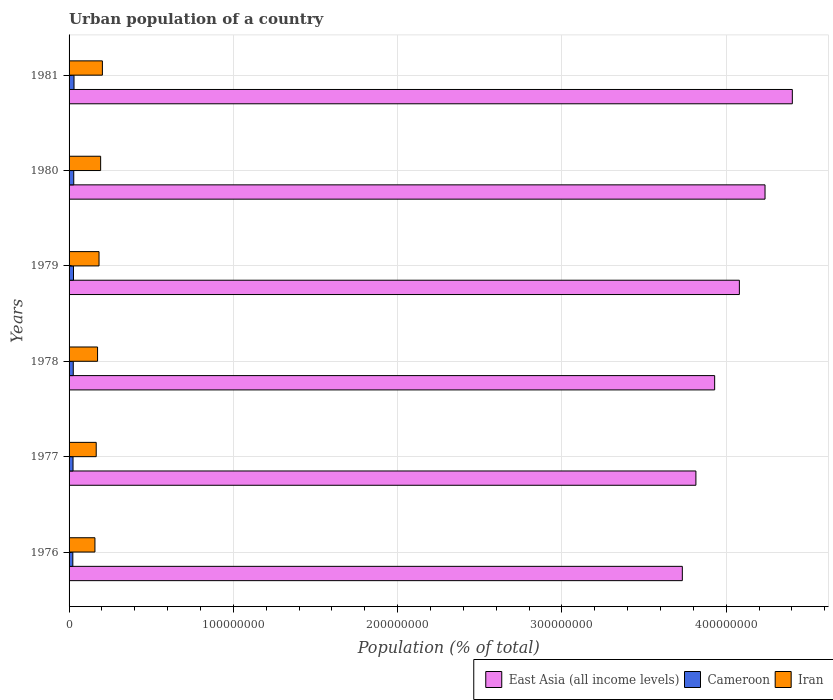How many different coloured bars are there?
Ensure brevity in your answer.  3. How many groups of bars are there?
Make the answer very short. 6. What is the label of the 6th group of bars from the top?
Your answer should be very brief. 1976. In how many cases, is the number of bars for a given year not equal to the number of legend labels?
Your answer should be very brief. 0. What is the urban population in Iran in 1977?
Your answer should be very brief. 1.65e+07. Across all years, what is the maximum urban population in Iran?
Your response must be concise. 2.03e+07. Across all years, what is the minimum urban population in Cameroon?
Offer a very short reply. 2.28e+06. In which year was the urban population in Iran maximum?
Your response must be concise. 1981. In which year was the urban population in Cameroon minimum?
Your answer should be very brief. 1976. What is the total urban population in Iran in the graph?
Ensure brevity in your answer.  1.07e+08. What is the difference between the urban population in Iran in 1978 and that in 1981?
Give a very brief answer. -2.93e+06. What is the difference between the urban population in Iran in 1978 and the urban population in Cameroon in 1977?
Give a very brief answer. 1.49e+07. What is the average urban population in Cameroon per year?
Offer a terse response. 2.63e+06. In the year 1976, what is the difference between the urban population in Cameroon and urban population in Iran?
Offer a terse response. -1.35e+07. What is the ratio of the urban population in East Asia (all income levels) in 1976 to that in 1978?
Ensure brevity in your answer.  0.95. Is the urban population in East Asia (all income levels) in 1976 less than that in 1977?
Your response must be concise. Yes. What is the difference between the highest and the second highest urban population in Iran?
Your response must be concise. 1.06e+06. What is the difference between the highest and the lowest urban population in Iran?
Make the answer very short. 4.53e+06. In how many years, is the urban population in Cameroon greater than the average urban population in Cameroon taken over all years?
Give a very brief answer. 3. Is the sum of the urban population in Cameroon in 1976 and 1978 greater than the maximum urban population in East Asia (all income levels) across all years?
Ensure brevity in your answer.  No. What does the 1st bar from the top in 1979 represents?
Give a very brief answer. Iran. What does the 3rd bar from the bottom in 1981 represents?
Ensure brevity in your answer.  Iran. Are all the bars in the graph horizontal?
Your response must be concise. Yes. How many years are there in the graph?
Make the answer very short. 6. What is the difference between two consecutive major ticks on the X-axis?
Offer a very short reply. 1.00e+08. Are the values on the major ticks of X-axis written in scientific E-notation?
Offer a terse response. No. Does the graph contain grids?
Your answer should be very brief. Yes. Where does the legend appear in the graph?
Your answer should be very brief. Bottom right. How many legend labels are there?
Make the answer very short. 3. How are the legend labels stacked?
Your answer should be compact. Horizontal. What is the title of the graph?
Give a very brief answer. Urban population of a country. What is the label or title of the X-axis?
Offer a very short reply. Population (% of total). What is the label or title of the Y-axis?
Offer a very short reply. Years. What is the Population (% of total) in East Asia (all income levels) in 1976?
Your answer should be very brief. 3.73e+08. What is the Population (% of total) in Cameroon in 1976?
Ensure brevity in your answer.  2.28e+06. What is the Population (% of total) of Iran in 1976?
Your answer should be very brief. 1.57e+07. What is the Population (% of total) of East Asia (all income levels) in 1977?
Provide a short and direct response. 3.82e+08. What is the Population (% of total) in Cameroon in 1977?
Your response must be concise. 2.41e+06. What is the Population (% of total) of Iran in 1977?
Your answer should be compact. 1.65e+07. What is the Population (% of total) of East Asia (all income levels) in 1978?
Give a very brief answer. 3.93e+08. What is the Population (% of total) of Cameroon in 1978?
Your response must be concise. 2.55e+06. What is the Population (% of total) of Iran in 1978?
Ensure brevity in your answer.  1.73e+07. What is the Population (% of total) in East Asia (all income levels) in 1979?
Offer a terse response. 4.08e+08. What is the Population (% of total) of Cameroon in 1979?
Give a very brief answer. 2.70e+06. What is the Population (% of total) in Iran in 1979?
Make the answer very short. 1.82e+07. What is the Population (% of total) of East Asia (all income levels) in 1980?
Your response must be concise. 4.24e+08. What is the Population (% of total) of Cameroon in 1980?
Your answer should be compact. 2.85e+06. What is the Population (% of total) in Iran in 1980?
Make the answer very short. 1.92e+07. What is the Population (% of total) of East Asia (all income levels) in 1981?
Give a very brief answer. 4.40e+08. What is the Population (% of total) of Cameroon in 1981?
Your answer should be compact. 3.01e+06. What is the Population (% of total) of Iran in 1981?
Your response must be concise. 2.03e+07. Across all years, what is the maximum Population (% of total) of East Asia (all income levels)?
Provide a succinct answer. 4.40e+08. Across all years, what is the maximum Population (% of total) in Cameroon?
Give a very brief answer. 3.01e+06. Across all years, what is the maximum Population (% of total) of Iran?
Offer a terse response. 2.03e+07. Across all years, what is the minimum Population (% of total) of East Asia (all income levels)?
Make the answer very short. 3.73e+08. Across all years, what is the minimum Population (% of total) of Cameroon?
Your answer should be very brief. 2.28e+06. Across all years, what is the minimum Population (% of total) of Iran?
Offer a very short reply. 1.57e+07. What is the total Population (% of total) in East Asia (all income levels) in the graph?
Offer a very short reply. 2.42e+09. What is the total Population (% of total) of Cameroon in the graph?
Your answer should be compact. 1.58e+07. What is the total Population (% of total) of Iran in the graph?
Ensure brevity in your answer.  1.07e+08. What is the difference between the Population (% of total) of East Asia (all income levels) in 1976 and that in 1977?
Keep it short and to the point. -8.27e+06. What is the difference between the Population (% of total) in Cameroon in 1976 and that in 1977?
Your answer should be very brief. -1.30e+05. What is the difference between the Population (% of total) of Iran in 1976 and that in 1977?
Provide a succinct answer. -7.82e+05. What is the difference between the Population (% of total) of East Asia (all income levels) in 1976 and that in 1978?
Provide a succinct answer. -1.97e+07. What is the difference between the Population (% of total) in Cameroon in 1976 and that in 1978?
Your response must be concise. -2.68e+05. What is the difference between the Population (% of total) of Iran in 1976 and that in 1978?
Provide a short and direct response. -1.60e+06. What is the difference between the Population (% of total) in East Asia (all income levels) in 1976 and that in 1979?
Offer a terse response. -3.47e+07. What is the difference between the Population (% of total) in Cameroon in 1976 and that in 1979?
Make the answer very short. -4.14e+05. What is the difference between the Population (% of total) of Iran in 1976 and that in 1979?
Provide a succinct answer. -2.49e+06. What is the difference between the Population (% of total) in East Asia (all income levels) in 1976 and that in 1980?
Your answer should be very brief. -5.03e+07. What is the difference between the Population (% of total) of Cameroon in 1976 and that in 1980?
Offer a terse response. -5.69e+05. What is the difference between the Population (% of total) of Iran in 1976 and that in 1980?
Offer a terse response. -3.47e+06. What is the difference between the Population (% of total) in East Asia (all income levels) in 1976 and that in 1981?
Provide a short and direct response. -6.70e+07. What is the difference between the Population (% of total) of Cameroon in 1976 and that in 1981?
Give a very brief answer. -7.32e+05. What is the difference between the Population (% of total) of Iran in 1976 and that in 1981?
Ensure brevity in your answer.  -4.53e+06. What is the difference between the Population (% of total) in East Asia (all income levels) in 1977 and that in 1978?
Make the answer very short. -1.14e+07. What is the difference between the Population (% of total) of Cameroon in 1977 and that in 1978?
Your answer should be compact. -1.38e+05. What is the difference between the Population (% of total) of Iran in 1977 and that in 1978?
Your response must be concise. -8.18e+05. What is the difference between the Population (% of total) in East Asia (all income levels) in 1977 and that in 1979?
Give a very brief answer. -2.65e+07. What is the difference between the Population (% of total) in Cameroon in 1977 and that in 1979?
Ensure brevity in your answer.  -2.84e+05. What is the difference between the Population (% of total) in Iran in 1977 and that in 1979?
Ensure brevity in your answer.  -1.71e+06. What is the difference between the Population (% of total) of East Asia (all income levels) in 1977 and that in 1980?
Your answer should be compact. -4.21e+07. What is the difference between the Population (% of total) of Cameroon in 1977 and that in 1980?
Offer a very short reply. -4.38e+05. What is the difference between the Population (% of total) of Iran in 1977 and that in 1980?
Your response must be concise. -2.69e+06. What is the difference between the Population (% of total) of East Asia (all income levels) in 1977 and that in 1981?
Provide a short and direct response. -5.87e+07. What is the difference between the Population (% of total) of Cameroon in 1977 and that in 1981?
Offer a very short reply. -6.02e+05. What is the difference between the Population (% of total) of Iran in 1977 and that in 1981?
Provide a succinct answer. -3.75e+06. What is the difference between the Population (% of total) of East Asia (all income levels) in 1978 and that in 1979?
Your response must be concise. -1.50e+07. What is the difference between the Population (% of total) in Cameroon in 1978 and that in 1979?
Give a very brief answer. -1.46e+05. What is the difference between the Population (% of total) of Iran in 1978 and that in 1979?
Keep it short and to the point. -8.93e+05. What is the difference between the Population (% of total) of East Asia (all income levels) in 1978 and that in 1980?
Make the answer very short. -3.07e+07. What is the difference between the Population (% of total) of Cameroon in 1978 and that in 1980?
Keep it short and to the point. -3.00e+05. What is the difference between the Population (% of total) in Iran in 1978 and that in 1980?
Ensure brevity in your answer.  -1.87e+06. What is the difference between the Population (% of total) in East Asia (all income levels) in 1978 and that in 1981?
Keep it short and to the point. -4.73e+07. What is the difference between the Population (% of total) in Cameroon in 1978 and that in 1981?
Ensure brevity in your answer.  -4.64e+05. What is the difference between the Population (% of total) of Iran in 1978 and that in 1981?
Your answer should be very brief. -2.93e+06. What is the difference between the Population (% of total) in East Asia (all income levels) in 1979 and that in 1980?
Your response must be concise. -1.56e+07. What is the difference between the Population (% of total) of Cameroon in 1979 and that in 1980?
Provide a succinct answer. -1.54e+05. What is the difference between the Population (% of total) of Iran in 1979 and that in 1980?
Your answer should be compact. -9.78e+05. What is the difference between the Population (% of total) of East Asia (all income levels) in 1979 and that in 1981?
Make the answer very short. -3.22e+07. What is the difference between the Population (% of total) in Cameroon in 1979 and that in 1981?
Provide a short and direct response. -3.18e+05. What is the difference between the Population (% of total) of Iran in 1979 and that in 1981?
Provide a short and direct response. -2.04e+06. What is the difference between the Population (% of total) of East Asia (all income levels) in 1980 and that in 1981?
Give a very brief answer. -1.66e+07. What is the difference between the Population (% of total) in Cameroon in 1980 and that in 1981?
Provide a short and direct response. -1.63e+05. What is the difference between the Population (% of total) of Iran in 1980 and that in 1981?
Provide a succinct answer. -1.06e+06. What is the difference between the Population (% of total) in East Asia (all income levels) in 1976 and the Population (% of total) in Cameroon in 1977?
Provide a succinct answer. 3.71e+08. What is the difference between the Population (% of total) in East Asia (all income levels) in 1976 and the Population (% of total) in Iran in 1977?
Provide a short and direct response. 3.57e+08. What is the difference between the Population (% of total) of Cameroon in 1976 and the Population (% of total) of Iran in 1977?
Your answer should be compact. -1.42e+07. What is the difference between the Population (% of total) of East Asia (all income levels) in 1976 and the Population (% of total) of Cameroon in 1978?
Offer a terse response. 3.71e+08. What is the difference between the Population (% of total) in East Asia (all income levels) in 1976 and the Population (% of total) in Iran in 1978?
Ensure brevity in your answer.  3.56e+08. What is the difference between the Population (% of total) in Cameroon in 1976 and the Population (% of total) in Iran in 1978?
Your response must be concise. -1.51e+07. What is the difference between the Population (% of total) of East Asia (all income levels) in 1976 and the Population (% of total) of Cameroon in 1979?
Ensure brevity in your answer.  3.71e+08. What is the difference between the Population (% of total) of East Asia (all income levels) in 1976 and the Population (% of total) of Iran in 1979?
Provide a succinct answer. 3.55e+08. What is the difference between the Population (% of total) in Cameroon in 1976 and the Population (% of total) in Iran in 1979?
Offer a terse response. -1.60e+07. What is the difference between the Population (% of total) in East Asia (all income levels) in 1976 and the Population (% of total) in Cameroon in 1980?
Your response must be concise. 3.70e+08. What is the difference between the Population (% of total) of East Asia (all income levels) in 1976 and the Population (% of total) of Iran in 1980?
Your response must be concise. 3.54e+08. What is the difference between the Population (% of total) of Cameroon in 1976 and the Population (% of total) of Iran in 1980?
Provide a succinct answer. -1.69e+07. What is the difference between the Population (% of total) in East Asia (all income levels) in 1976 and the Population (% of total) in Cameroon in 1981?
Keep it short and to the point. 3.70e+08. What is the difference between the Population (% of total) of East Asia (all income levels) in 1976 and the Population (% of total) of Iran in 1981?
Offer a very short reply. 3.53e+08. What is the difference between the Population (% of total) of Cameroon in 1976 and the Population (% of total) of Iran in 1981?
Make the answer very short. -1.80e+07. What is the difference between the Population (% of total) of East Asia (all income levels) in 1977 and the Population (% of total) of Cameroon in 1978?
Provide a short and direct response. 3.79e+08. What is the difference between the Population (% of total) in East Asia (all income levels) in 1977 and the Population (% of total) in Iran in 1978?
Offer a very short reply. 3.64e+08. What is the difference between the Population (% of total) of Cameroon in 1977 and the Population (% of total) of Iran in 1978?
Offer a very short reply. -1.49e+07. What is the difference between the Population (% of total) of East Asia (all income levels) in 1977 and the Population (% of total) of Cameroon in 1979?
Your response must be concise. 3.79e+08. What is the difference between the Population (% of total) of East Asia (all income levels) in 1977 and the Population (% of total) of Iran in 1979?
Your answer should be very brief. 3.63e+08. What is the difference between the Population (% of total) of Cameroon in 1977 and the Population (% of total) of Iran in 1979?
Offer a terse response. -1.58e+07. What is the difference between the Population (% of total) in East Asia (all income levels) in 1977 and the Population (% of total) in Cameroon in 1980?
Ensure brevity in your answer.  3.79e+08. What is the difference between the Population (% of total) of East Asia (all income levels) in 1977 and the Population (% of total) of Iran in 1980?
Provide a succinct answer. 3.62e+08. What is the difference between the Population (% of total) of Cameroon in 1977 and the Population (% of total) of Iran in 1980?
Provide a succinct answer. -1.68e+07. What is the difference between the Population (% of total) in East Asia (all income levels) in 1977 and the Population (% of total) in Cameroon in 1981?
Keep it short and to the point. 3.79e+08. What is the difference between the Population (% of total) in East Asia (all income levels) in 1977 and the Population (% of total) in Iran in 1981?
Your response must be concise. 3.61e+08. What is the difference between the Population (% of total) of Cameroon in 1977 and the Population (% of total) of Iran in 1981?
Keep it short and to the point. -1.79e+07. What is the difference between the Population (% of total) of East Asia (all income levels) in 1978 and the Population (% of total) of Cameroon in 1979?
Make the answer very short. 3.90e+08. What is the difference between the Population (% of total) of East Asia (all income levels) in 1978 and the Population (% of total) of Iran in 1979?
Your response must be concise. 3.75e+08. What is the difference between the Population (% of total) of Cameroon in 1978 and the Population (% of total) of Iran in 1979?
Keep it short and to the point. -1.57e+07. What is the difference between the Population (% of total) of East Asia (all income levels) in 1978 and the Population (% of total) of Cameroon in 1980?
Keep it short and to the point. 3.90e+08. What is the difference between the Population (% of total) in East Asia (all income levels) in 1978 and the Population (% of total) in Iran in 1980?
Ensure brevity in your answer.  3.74e+08. What is the difference between the Population (% of total) in Cameroon in 1978 and the Population (% of total) in Iran in 1980?
Your response must be concise. -1.67e+07. What is the difference between the Population (% of total) of East Asia (all income levels) in 1978 and the Population (% of total) of Cameroon in 1981?
Make the answer very short. 3.90e+08. What is the difference between the Population (% of total) in East Asia (all income levels) in 1978 and the Population (% of total) in Iran in 1981?
Provide a short and direct response. 3.73e+08. What is the difference between the Population (% of total) of Cameroon in 1978 and the Population (% of total) of Iran in 1981?
Ensure brevity in your answer.  -1.77e+07. What is the difference between the Population (% of total) in East Asia (all income levels) in 1979 and the Population (% of total) in Cameroon in 1980?
Offer a very short reply. 4.05e+08. What is the difference between the Population (% of total) of East Asia (all income levels) in 1979 and the Population (% of total) of Iran in 1980?
Make the answer very short. 3.89e+08. What is the difference between the Population (% of total) in Cameroon in 1979 and the Population (% of total) in Iran in 1980?
Ensure brevity in your answer.  -1.65e+07. What is the difference between the Population (% of total) of East Asia (all income levels) in 1979 and the Population (% of total) of Cameroon in 1981?
Offer a terse response. 4.05e+08. What is the difference between the Population (% of total) in East Asia (all income levels) in 1979 and the Population (% of total) in Iran in 1981?
Make the answer very short. 3.88e+08. What is the difference between the Population (% of total) in Cameroon in 1979 and the Population (% of total) in Iran in 1981?
Your response must be concise. -1.76e+07. What is the difference between the Population (% of total) in East Asia (all income levels) in 1980 and the Population (% of total) in Cameroon in 1981?
Your response must be concise. 4.21e+08. What is the difference between the Population (% of total) in East Asia (all income levels) in 1980 and the Population (% of total) in Iran in 1981?
Give a very brief answer. 4.03e+08. What is the difference between the Population (% of total) of Cameroon in 1980 and the Population (% of total) of Iran in 1981?
Make the answer very short. -1.74e+07. What is the average Population (% of total) in East Asia (all income levels) per year?
Your answer should be compact. 4.03e+08. What is the average Population (% of total) in Cameroon per year?
Provide a succinct answer. 2.63e+06. What is the average Population (% of total) of Iran per year?
Your answer should be compact. 1.79e+07. In the year 1976, what is the difference between the Population (% of total) of East Asia (all income levels) and Population (% of total) of Cameroon?
Give a very brief answer. 3.71e+08. In the year 1976, what is the difference between the Population (% of total) in East Asia (all income levels) and Population (% of total) in Iran?
Offer a terse response. 3.58e+08. In the year 1976, what is the difference between the Population (% of total) in Cameroon and Population (% of total) in Iran?
Your response must be concise. -1.35e+07. In the year 1977, what is the difference between the Population (% of total) of East Asia (all income levels) and Population (% of total) of Cameroon?
Make the answer very short. 3.79e+08. In the year 1977, what is the difference between the Population (% of total) in East Asia (all income levels) and Population (% of total) in Iran?
Ensure brevity in your answer.  3.65e+08. In the year 1977, what is the difference between the Population (% of total) in Cameroon and Population (% of total) in Iran?
Keep it short and to the point. -1.41e+07. In the year 1978, what is the difference between the Population (% of total) in East Asia (all income levels) and Population (% of total) in Cameroon?
Keep it short and to the point. 3.90e+08. In the year 1978, what is the difference between the Population (% of total) of East Asia (all income levels) and Population (% of total) of Iran?
Your answer should be compact. 3.76e+08. In the year 1978, what is the difference between the Population (% of total) of Cameroon and Population (% of total) of Iran?
Your answer should be very brief. -1.48e+07. In the year 1979, what is the difference between the Population (% of total) in East Asia (all income levels) and Population (% of total) in Cameroon?
Offer a very short reply. 4.05e+08. In the year 1979, what is the difference between the Population (% of total) of East Asia (all income levels) and Population (% of total) of Iran?
Provide a succinct answer. 3.90e+08. In the year 1979, what is the difference between the Population (% of total) of Cameroon and Population (% of total) of Iran?
Keep it short and to the point. -1.55e+07. In the year 1980, what is the difference between the Population (% of total) of East Asia (all income levels) and Population (% of total) of Cameroon?
Offer a terse response. 4.21e+08. In the year 1980, what is the difference between the Population (% of total) in East Asia (all income levels) and Population (% of total) in Iran?
Make the answer very short. 4.04e+08. In the year 1980, what is the difference between the Population (% of total) in Cameroon and Population (% of total) in Iran?
Give a very brief answer. -1.64e+07. In the year 1981, what is the difference between the Population (% of total) in East Asia (all income levels) and Population (% of total) in Cameroon?
Offer a very short reply. 4.37e+08. In the year 1981, what is the difference between the Population (% of total) in East Asia (all income levels) and Population (% of total) in Iran?
Offer a terse response. 4.20e+08. In the year 1981, what is the difference between the Population (% of total) in Cameroon and Population (% of total) in Iran?
Give a very brief answer. -1.73e+07. What is the ratio of the Population (% of total) of East Asia (all income levels) in 1976 to that in 1977?
Provide a short and direct response. 0.98. What is the ratio of the Population (% of total) of Cameroon in 1976 to that in 1977?
Your response must be concise. 0.95. What is the ratio of the Population (% of total) of Iran in 1976 to that in 1977?
Your answer should be very brief. 0.95. What is the ratio of the Population (% of total) of East Asia (all income levels) in 1976 to that in 1978?
Keep it short and to the point. 0.95. What is the ratio of the Population (% of total) of Cameroon in 1976 to that in 1978?
Provide a short and direct response. 0.89. What is the ratio of the Population (% of total) of Iran in 1976 to that in 1978?
Make the answer very short. 0.91. What is the ratio of the Population (% of total) of East Asia (all income levels) in 1976 to that in 1979?
Give a very brief answer. 0.91. What is the ratio of the Population (% of total) in Cameroon in 1976 to that in 1979?
Keep it short and to the point. 0.85. What is the ratio of the Population (% of total) in Iran in 1976 to that in 1979?
Ensure brevity in your answer.  0.86. What is the ratio of the Population (% of total) of East Asia (all income levels) in 1976 to that in 1980?
Offer a terse response. 0.88. What is the ratio of the Population (% of total) of Cameroon in 1976 to that in 1980?
Your answer should be compact. 0.8. What is the ratio of the Population (% of total) in Iran in 1976 to that in 1980?
Keep it short and to the point. 0.82. What is the ratio of the Population (% of total) in East Asia (all income levels) in 1976 to that in 1981?
Ensure brevity in your answer.  0.85. What is the ratio of the Population (% of total) of Cameroon in 1976 to that in 1981?
Your answer should be very brief. 0.76. What is the ratio of the Population (% of total) of Iran in 1976 to that in 1981?
Provide a short and direct response. 0.78. What is the ratio of the Population (% of total) in East Asia (all income levels) in 1977 to that in 1978?
Provide a short and direct response. 0.97. What is the ratio of the Population (% of total) in Cameroon in 1977 to that in 1978?
Keep it short and to the point. 0.95. What is the ratio of the Population (% of total) of Iran in 1977 to that in 1978?
Give a very brief answer. 0.95. What is the ratio of the Population (% of total) in East Asia (all income levels) in 1977 to that in 1979?
Provide a short and direct response. 0.94. What is the ratio of the Population (% of total) in Cameroon in 1977 to that in 1979?
Your response must be concise. 0.89. What is the ratio of the Population (% of total) in Iran in 1977 to that in 1979?
Your response must be concise. 0.91. What is the ratio of the Population (% of total) in East Asia (all income levels) in 1977 to that in 1980?
Keep it short and to the point. 0.9. What is the ratio of the Population (% of total) of Cameroon in 1977 to that in 1980?
Your response must be concise. 0.85. What is the ratio of the Population (% of total) of Iran in 1977 to that in 1980?
Offer a very short reply. 0.86. What is the ratio of the Population (% of total) of East Asia (all income levels) in 1977 to that in 1981?
Make the answer very short. 0.87. What is the ratio of the Population (% of total) in Cameroon in 1977 to that in 1981?
Give a very brief answer. 0.8. What is the ratio of the Population (% of total) in Iran in 1977 to that in 1981?
Your answer should be very brief. 0.81. What is the ratio of the Population (% of total) of East Asia (all income levels) in 1978 to that in 1979?
Keep it short and to the point. 0.96. What is the ratio of the Population (% of total) of Cameroon in 1978 to that in 1979?
Your answer should be compact. 0.95. What is the ratio of the Population (% of total) in Iran in 1978 to that in 1979?
Your answer should be very brief. 0.95. What is the ratio of the Population (% of total) of East Asia (all income levels) in 1978 to that in 1980?
Give a very brief answer. 0.93. What is the ratio of the Population (% of total) in Cameroon in 1978 to that in 1980?
Offer a terse response. 0.89. What is the ratio of the Population (% of total) in Iran in 1978 to that in 1980?
Your response must be concise. 0.9. What is the ratio of the Population (% of total) of East Asia (all income levels) in 1978 to that in 1981?
Your response must be concise. 0.89. What is the ratio of the Population (% of total) in Cameroon in 1978 to that in 1981?
Give a very brief answer. 0.85. What is the ratio of the Population (% of total) in Iran in 1978 to that in 1981?
Offer a very short reply. 0.86. What is the ratio of the Population (% of total) in East Asia (all income levels) in 1979 to that in 1980?
Your answer should be compact. 0.96. What is the ratio of the Population (% of total) in Cameroon in 1979 to that in 1980?
Provide a succinct answer. 0.95. What is the ratio of the Population (% of total) in Iran in 1979 to that in 1980?
Provide a short and direct response. 0.95. What is the ratio of the Population (% of total) of East Asia (all income levels) in 1979 to that in 1981?
Offer a terse response. 0.93. What is the ratio of the Population (% of total) in Cameroon in 1979 to that in 1981?
Give a very brief answer. 0.89. What is the ratio of the Population (% of total) of Iran in 1979 to that in 1981?
Offer a very short reply. 0.9. What is the ratio of the Population (% of total) in East Asia (all income levels) in 1980 to that in 1981?
Keep it short and to the point. 0.96. What is the ratio of the Population (% of total) of Cameroon in 1980 to that in 1981?
Your answer should be compact. 0.95. What is the ratio of the Population (% of total) in Iran in 1980 to that in 1981?
Your response must be concise. 0.95. What is the difference between the highest and the second highest Population (% of total) of East Asia (all income levels)?
Offer a terse response. 1.66e+07. What is the difference between the highest and the second highest Population (% of total) in Cameroon?
Keep it short and to the point. 1.63e+05. What is the difference between the highest and the second highest Population (% of total) of Iran?
Provide a short and direct response. 1.06e+06. What is the difference between the highest and the lowest Population (% of total) of East Asia (all income levels)?
Offer a terse response. 6.70e+07. What is the difference between the highest and the lowest Population (% of total) of Cameroon?
Offer a terse response. 7.32e+05. What is the difference between the highest and the lowest Population (% of total) in Iran?
Offer a terse response. 4.53e+06. 